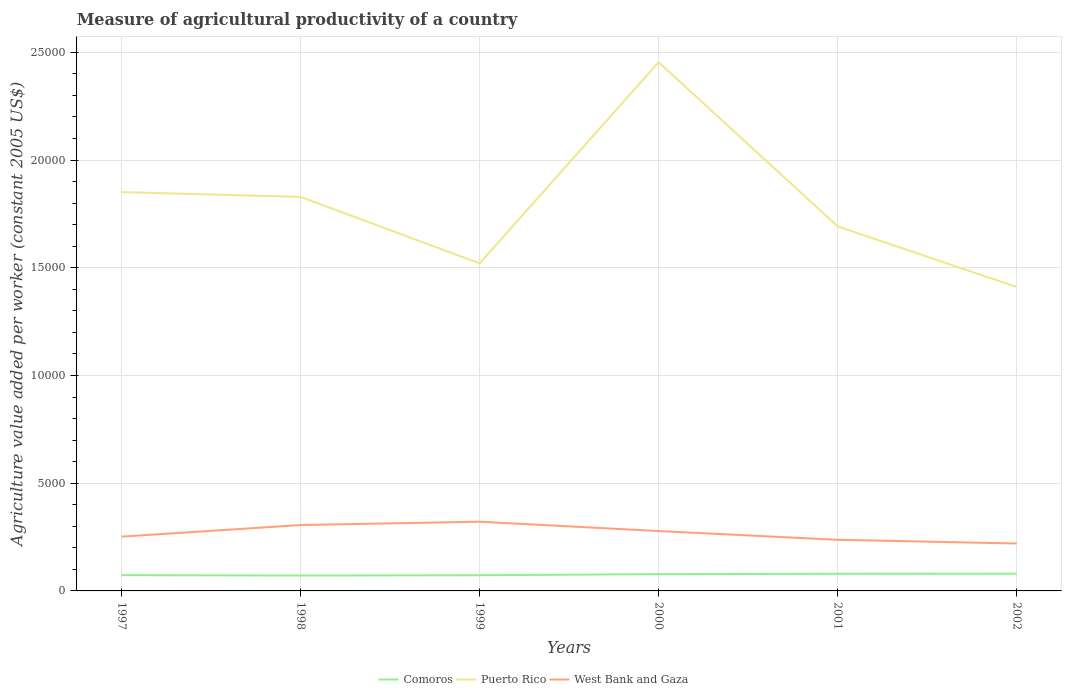Is the number of lines equal to the number of legend labels?
Make the answer very short. Yes. Across all years, what is the maximum measure of agricultural productivity in Puerto Rico?
Your answer should be very brief. 1.41e+04. In which year was the measure of agricultural productivity in West Bank and Gaza maximum?
Offer a very short reply. 2002. What is the total measure of agricultural productivity in Puerto Rico in the graph?
Your answer should be compact. -1714.63. What is the difference between the highest and the second highest measure of agricultural productivity in West Bank and Gaza?
Ensure brevity in your answer.  1012.13. What is the difference between the highest and the lowest measure of agricultural productivity in West Bank and Gaza?
Your answer should be very brief. 3. Is the measure of agricultural productivity in Comoros strictly greater than the measure of agricultural productivity in West Bank and Gaza over the years?
Your answer should be compact. Yes. Are the values on the major ticks of Y-axis written in scientific E-notation?
Your answer should be very brief. No. Does the graph contain any zero values?
Provide a succinct answer. No. Where does the legend appear in the graph?
Keep it short and to the point. Bottom center. What is the title of the graph?
Your answer should be very brief. Measure of agricultural productivity of a country. Does "Djibouti" appear as one of the legend labels in the graph?
Give a very brief answer. No. What is the label or title of the X-axis?
Provide a succinct answer. Years. What is the label or title of the Y-axis?
Your response must be concise. Agriculture value added per worker (constant 2005 US$). What is the Agriculture value added per worker (constant 2005 US$) of Comoros in 1997?
Your answer should be compact. 731.41. What is the Agriculture value added per worker (constant 2005 US$) of Puerto Rico in 1997?
Your answer should be very brief. 1.85e+04. What is the Agriculture value added per worker (constant 2005 US$) in West Bank and Gaza in 1997?
Your answer should be compact. 2520.14. What is the Agriculture value added per worker (constant 2005 US$) of Comoros in 1998?
Your answer should be compact. 714.18. What is the Agriculture value added per worker (constant 2005 US$) in Puerto Rico in 1998?
Your answer should be very brief. 1.83e+04. What is the Agriculture value added per worker (constant 2005 US$) of West Bank and Gaza in 1998?
Offer a very short reply. 3057.49. What is the Agriculture value added per worker (constant 2005 US$) of Comoros in 1999?
Offer a terse response. 727.74. What is the Agriculture value added per worker (constant 2005 US$) of Puerto Rico in 1999?
Keep it short and to the point. 1.52e+04. What is the Agriculture value added per worker (constant 2005 US$) in West Bank and Gaza in 1999?
Make the answer very short. 3212.81. What is the Agriculture value added per worker (constant 2005 US$) in Comoros in 2000?
Your answer should be very brief. 778.83. What is the Agriculture value added per worker (constant 2005 US$) in Puerto Rico in 2000?
Make the answer very short. 2.45e+04. What is the Agriculture value added per worker (constant 2005 US$) in West Bank and Gaza in 2000?
Provide a short and direct response. 2778.67. What is the Agriculture value added per worker (constant 2005 US$) in Comoros in 2001?
Ensure brevity in your answer.  796.84. What is the Agriculture value added per worker (constant 2005 US$) of Puerto Rico in 2001?
Give a very brief answer. 1.69e+04. What is the Agriculture value added per worker (constant 2005 US$) in West Bank and Gaza in 2001?
Keep it short and to the point. 2373.17. What is the Agriculture value added per worker (constant 2005 US$) of Comoros in 2002?
Your response must be concise. 800.25. What is the Agriculture value added per worker (constant 2005 US$) of Puerto Rico in 2002?
Make the answer very short. 1.41e+04. What is the Agriculture value added per worker (constant 2005 US$) in West Bank and Gaza in 2002?
Your response must be concise. 2200.68. Across all years, what is the maximum Agriculture value added per worker (constant 2005 US$) in Comoros?
Your answer should be very brief. 800.25. Across all years, what is the maximum Agriculture value added per worker (constant 2005 US$) of Puerto Rico?
Make the answer very short. 2.45e+04. Across all years, what is the maximum Agriculture value added per worker (constant 2005 US$) in West Bank and Gaza?
Provide a short and direct response. 3212.81. Across all years, what is the minimum Agriculture value added per worker (constant 2005 US$) of Comoros?
Your answer should be compact. 714.18. Across all years, what is the minimum Agriculture value added per worker (constant 2005 US$) of Puerto Rico?
Give a very brief answer. 1.41e+04. Across all years, what is the minimum Agriculture value added per worker (constant 2005 US$) of West Bank and Gaza?
Ensure brevity in your answer.  2200.68. What is the total Agriculture value added per worker (constant 2005 US$) in Comoros in the graph?
Provide a short and direct response. 4549.26. What is the total Agriculture value added per worker (constant 2005 US$) of Puerto Rico in the graph?
Make the answer very short. 1.08e+05. What is the total Agriculture value added per worker (constant 2005 US$) of West Bank and Gaza in the graph?
Your answer should be compact. 1.61e+04. What is the difference between the Agriculture value added per worker (constant 2005 US$) of Comoros in 1997 and that in 1998?
Your answer should be compact. 17.24. What is the difference between the Agriculture value added per worker (constant 2005 US$) in Puerto Rico in 1997 and that in 1998?
Give a very brief answer. 222.44. What is the difference between the Agriculture value added per worker (constant 2005 US$) in West Bank and Gaza in 1997 and that in 1998?
Offer a very short reply. -537.35. What is the difference between the Agriculture value added per worker (constant 2005 US$) in Comoros in 1997 and that in 1999?
Your answer should be very brief. 3.67. What is the difference between the Agriculture value added per worker (constant 2005 US$) of Puerto Rico in 1997 and that in 1999?
Give a very brief answer. 3308.77. What is the difference between the Agriculture value added per worker (constant 2005 US$) in West Bank and Gaza in 1997 and that in 1999?
Ensure brevity in your answer.  -692.67. What is the difference between the Agriculture value added per worker (constant 2005 US$) in Comoros in 1997 and that in 2000?
Provide a short and direct response. -47.42. What is the difference between the Agriculture value added per worker (constant 2005 US$) in Puerto Rico in 1997 and that in 2000?
Your answer should be compact. -6026.43. What is the difference between the Agriculture value added per worker (constant 2005 US$) in West Bank and Gaza in 1997 and that in 2000?
Provide a succinct answer. -258.53. What is the difference between the Agriculture value added per worker (constant 2005 US$) in Comoros in 1997 and that in 2001?
Your response must be concise. -65.43. What is the difference between the Agriculture value added per worker (constant 2005 US$) in Puerto Rico in 1997 and that in 2001?
Your answer should be very brief. 1594.14. What is the difference between the Agriculture value added per worker (constant 2005 US$) of West Bank and Gaza in 1997 and that in 2001?
Offer a terse response. 146.97. What is the difference between the Agriculture value added per worker (constant 2005 US$) in Comoros in 1997 and that in 2002?
Your response must be concise. -68.84. What is the difference between the Agriculture value added per worker (constant 2005 US$) of Puerto Rico in 1997 and that in 2002?
Make the answer very short. 4405.29. What is the difference between the Agriculture value added per worker (constant 2005 US$) of West Bank and Gaza in 1997 and that in 2002?
Keep it short and to the point. 319.46. What is the difference between the Agriculture value added per worker (constant 2005 US$) in Comoros in 1998 and that in 1999?
Provide a short and direct response. -13.57. What is the difference between the Agriculture value added per worker (constant 2005 US$) of Puerto Rico in 1998 and that in 1999?
Ensure brevity in your answer.  3086.33. What is the difference between the Agriculture value added per worker (constant 2005 US$) in West Bank and Gaza in 1998 and that in 1999?
Your response must be concise. -155.32. What is the difference between the Agriculture value added per worker (constant 2005 US$) in Comoros in 1998 and that in 2000?
Offer a terse response. -64.65. What is the difference between the Agriculture value added per worker (constant 2005 US$) of Puerto Rico in 1998 and that in 2000?
Provide a short and direct response. -6248.87. What is the difference between the Agriculture value added per worker (constant 2005 US$) of West Bank and Gaza in 1998 and that in 2000?
Offer a terse response. 278.81. What is the difference between the Agriculture value added per worker (constant 2005 US$) of Comoros in 1998 and that in 2001?
Offer a very short reply. -82.66. What is the difference between the Agriculture value added per worker (constant 2005 US$) in Puerto Rico in 1998 and that in 2001?
Your answer should be compact. 1371.7. What is the difference between the Agriculture value added per worker (constant 2005 US$) in West Bank and Gaza in 1998 and that in 2001?
Offer a very short reply. 684.31. What is the difference between the Agriculture value added per worker (constant 2005 US$) of Comoros in 1998 and that in 2002?
Offer a terse response. -86.07. What is the difference between the Agriculture value added per worker (constant 2005 US$) of Puerto Rico in 1998 and that in 2002?
Your answer should be compact. 4182.85. What is the difference between the Agriculture value added per worker (constant 2005 US$) of West Bank and Gaza in 1998 and that in 2002?
Ensure brevity in your answer.  856.81. What is the difference between the Agriculture value added per worker (constant 2005 US$) of Comoros in 1999 and that in 2000?
Your answer should be compact. -51.09. What is the difference between the Agriculture value added per worker (constant 2005 US$) in Puerto Rico in 1999 and that in 2000?
Provide a succinct answer. -9335.2. What is the difference between the Agriculture value added per worker (constant 2005 US$) in West Bank and Gaza in 1999 and that in 2000?
Ensure brevity in your answer.  434.13. What is the difference between the Agriculture value added per worker (constant 2005 US$) of Comoros in 1999 and that in 2001?
Ensure brevity in your answer.  -69.1. What is the difference between the Agriculture value added per worker (constant 2005 US$) in Puerto Rico in 1999 and that in 2001?
Ensure brevity in your answer.  -1714.63. What is the difference between the Agriculture value added per worker (constant 2005 US$) of West Bank and Gaza in 1999 and that in 2001?
Ensure brevity in your answer.  839.63. What is the difference between the Agriculture value added per worker (constant 2005 US$) of Comoros in 1999 and that in 2002?
Your answer should be compact. -72.51. What is the difference between the Agriculture value added per worker (constant 2005 US$) in Puerto Rico in 1999 and that in 2002?
Your answer should be very brief. 1096.52. What is the difference between the Agriculture value added per worker (constant 2005 US$) of West Bank and Gaza in 1999 and that in 2002?
Offer a terse response. 1012.13. What is the difference between the Agriculture value added per worker (constant 2005 US$) of Comoros in 2000 and that in 2001?
Your answer should be compact. -18.01. What is the difference between the Agriculture value added per worker (constant 2005 US$) of Puerto Rico in 2000 and that in 2001?
Keep it short and to the point. 7620.57. What is the difference between the Agriculture value added per worker (constant 2005 US$) in West Bank and Gaza in 2000 and that in 2001?
Your answer should be very brief. 405.5. What is the difference between the Agriculture value added per worker (constant 2005 US$) in Comoros in 2000 and that in 2002?
Provide a succinct answer. -21.42. What is the difference between the Agriculture value added per worker (constant 2005 US$) of Puerto Rico in 2000 and that in 2002?
Provide a succinct answer. 1.04e+04. What is the difference between the Agriculture value added per worker (constant 2005 US$) in West Bank and Gaza in 2000 and that in 2002?
Ensure brevity in your answer.  577.99. What is the difference between the Agriculture value added per worker (constant 2005 US$) of Comoros in 2001 and that in 2002?
Provide a short and direct response. -3.41. What is the difference between the Agriculture value added per worker (constant 2005 US$) of Puerto Rico in 2001 and that in 2002?
Keep it short and to the point. 2811.15. What is the difference between the Agriculture value added per worker (constant 2005 US$) in West Bank and Gaza in 2001 and that in 2002?
Offer a very short reply. 172.49. What is the difference between the Agriculture value added per worker (constant 2005 US$) of Comoros in 1997 and the Agriculture value added per worker (constant 2005 US$) of Puerto Rico in 1998?
Your answer should be compact. -1.76e+04. What is the difference between the Agriculture value added per worker (constant 2005 US$) of Comoros in 1997 and the Agriculture value added per worker (constant 2005 US$) of West Bank and Gaza in 1998?
Your response must be concise. -2326.07. What is the difference between the Agriculture value added per worker (constant 2005 US$) of Puerto Rico in 1997 and the Agriculture value added per worker (constant 2005 US$) of West Bank and Gaza in 1998?
Provide a short and direct response. 1.55e+04. What is the difference between the Agriculture value added per worker (constant 2005 US$) of Comoros in 1997 and the Agriculture value added per worker (constant 2005 US$) of Puerto Rico in 1999?
Keep it short and to the point. -1.45e+04. What is the difference between the Agriculture value added per worker (constant 2005 US$) in Comoros in 1997 and the Agriculture value added per worker (constant 2005 US$) in West Bank and Gaza in 1999?
Provide a succinct answer. -2481.39. What is the difference between the Agriculture value added per worker (constant 2005 US$) in Puerto Rico in 1997 and the Agriculture value added per worker (constant 2005 US$) in West Bank and Gaza in 1999?
Your answer should be very brief. 1.53e+04. What is the difference between the Agriculture value added per worker (constant 2005 US$) in Comoros in 1997 and the Agriculture value added per worker (constant 2005 US$) in Puerto Rico in 2000?
Your response must be concise. -2.38e+04. What is the difference between the Agriculture value added per worker (constant 2005 US$) in Comoros in 1997 and the Agriculture value added per worker (constant 2005 US$) in West Bank and Gaza in 2000?
Your answer should be compact. -2047.26. What is the difference between the Agriculture value added per worker (constant 2005 US$) of Puerto Rico in 1997 and the Agriculture value added per worker (constant 2005 US$) of West Bank and Gaza in 2000?
Make the answer very short. 1.57e+04. What is the difference between the Agriculture value added per worker (constant 2005 US$) in Comoros in 1997 and the Agriculture value added per worker (constant 2005 US$) in Puerto Rico in 2001?
Your response must be concise. -1.62e+04. What is the difference between the Agriculture value added per worker (constant 2005 US$) in Comoros in 1997 and the Agriculture value added per worker (constant 2005 US$) in West Bank and Gaza in 2001?
Make the answer very short. -1641.76. What is the difference between the Agriculture value added per worker (constant 2005 US$) in Puerto Rico in 1997 and the Agriculture value added per worker (constant 2005 US$) in West Bank and Gaza in 2001?
Offer a terse response. 1.61e+04. What is the difference between the Agriculture value added per worker (constant 2005 US$) in Comoros in 1997 and the Agriculture value added per worker (constant 2005 US$) in Puerto Rico in 2002?
Offer a very short reply. -1.34e+04. What is the difference between the Agriculture value added per worker (constant 2005 US$) of Comoros in 1997 and the Agriculture value added per worker (constant 2005 US$) of West Bank and Gaza in 2002?
Ensure brevity in your answer.  -1469.27. What is the difference between the Agriculture value added per worker (constant 2005 US$) in Puerto Rico in 1997 and the Agriculture value added per worker (constant 2005 US$) in West Bank and Gaza in 2002?
Give a very brief answer. 1.63e+04. What is the difference between the Agriculture value added per worker (constant 2005 US$) in Comoros in 1998 and the Agriculture value added per worker (constant 2005 US$) in Puerto Rico in 1999?
Make the answer very short. -1.45e+04. What is the difference between the Agriculture value added per worker (constant 2005 US$) in Comoros in 1998 and the Agriculture value added per worker (constant 2005 US$) in West Bank and Gaza in 1999?
Provide a succinct answer. -2498.63. What is the difference between the Agriculture value added per worker (constant 2005 US$) of Puerto Rico in 1998 and the Agriculture value added per worker (constant 2005 US$) of West Bank and Gaza in 1999?
Your response must be concise. 1.51e+04. What is the difference between the Agriculture value added per worker (constant 2005 US$) of Comoros in 1998 and the Agriculture value added per worker (constant 2005 US$) of Puerto Rico in 2000?
Make the answer very short. -2.38e+04. What is the difference between the Agriculture value added per worker (constant 2005 US$) in Comoros in 1998 and the Agriculture value added per worker (constant 2005 US$) in West Bank and Gaza in 2000?
Give a very brief answer. -2064.49. What is the difference between the Agriculture value added per worker (constant 2005 US$) of Puerto Rico in 1998 and the Agriculture value added per worker (constant 2005 US$) of West Bank and Gaza in 2000?
Offer a terse response. 1.55e+04. What is the difference between the Agriculture value added per worker (constant 2005 US$) in Comoros in 1998 and the Agriculture value added per worker (constant 2005 US$) in Puerto Rico in 2001?
Ensure brevity in your answer.  -1.62e+04. What is the difference between the Agriculture value added per worker (constant 2005 US$) of Comoros in 1998 and the Agriculture value added per worker (constant 2005 US$) of West Bank and Gaza in 2001?
Make the answer very short. -1658.99. What is the difference between the Agriculture value added per worker (constant 2005 US$) of Puerto Rico in 1998 and the Agriculture value added per worker (constant 2005 US$) of West Bank and Gaza in 2001?
Keep it short and to the point. 1.59e+04. What is the difference between the Agriculture value added per worker (constant 2005 US$) in Comoros in 1998 and the Agriculture value added per worker (constant 2005 US$) in Puerto Rico in 2002?
Ensure brevity in your answer.  -1.34e+04. What is the difference between the Agriculture value added per worker (constant 2005 US$) of Comoros in 1998 and the Agriculture value added per worker (constant 2005 US$) of West Bank and Gaza in 2002?
Your answer should be compact. -1486.5. What is the difference between the Agriculture value added per worker (constant 2005 US$) in Puerto Rico in 1998 and the Agriculture value added per worker (constant 2005 US$) in West Bank and Gaza in 2002?
Provide a short and direct response. 1.61e+04. What is the difference between the Agriculture value added per worker (constant 2005 US$) in Comoros in 1999 and the Agriculture value added per worker (constant 2005 US$) in Puerto Rico in 2000?
Ensure brevity in your answer.  -2.38e+04. What is the difference between the Agriculture value added per worker (constant 2005 US$) in Comoros in 1999 and the Agriculture value added per worker (constant 2005 US$) in West Bank and Gaza in 2000?
Offer a very short reply. -2050.93. What is the difference between the Agriculture value added per worker (constant 2005 US$) of Puerto Rico in 1999 and the Agriculture value added per worker (constant 2005 US$) of West Bank and Gaza in 2000?
Your response must be concise. 1.24e+04. What is the difference between the Agriculture value added per worker (constant 2005 US$) in Comoros in 1999 and the Agriculture value added per worker (constant 2005 US$) in Puerto Rico in 2001?
Your response must be concise. -1.62e+04. What is the difference between the Agriculture value added per worker (constant 2005 US$) of Comoros in 1999 and the Agriculture value added per worker (constant 2005 US$) of West Bank and Gaza in 2001?
Your response must be concise. -1645.43. What is the difference between the Agriculture value added per worker (constant 2005 US$) in Puerto Rico in 1999 and the Agriculture value added per worker (constant 2005 US$) in West Bank and Gaza in 2001?
Your answer should be very brief. 1.28e+04. What is the difference between the Agriculture value added per worker (constant 2005 US$) of Comoros in 1999 and the Agriculture value added per worker (constant 2005 US$) of Puerto Rico in 2002?
Give a very brief answer. -1.34e+04. What is the difference between the Agriculture value added per worker (constant 2005 US$) of Comoros in 1999 and the Agriculture value added per worker (constant 2005 US$) of West Bank and Gaza in 2002?
Ensure brevity in your answer.  -1472.94. What is the difference between the Agriculture value added per worker (constant 2005 US$) in Puerto Rico in 1999 and the Agriculture value added per worker (constant 2005 US$) in West Bank and Gaza in 2002?
Provide a succinct answer. 1.30e+04. What is the difference between the Agriculture value added per worker (constant 2005 US$) of Comoros in 2000 and the Agriculture value added per worker (constant 2005 US$) of Puerto Rico in 2001?
Make the answer very short. -1.61e+04. What is the difference between the Agriculture value added per worker (constant 2005 US$) in Comoros in 2000 and the Agriculture value added per worker (constant 2005 US$) in West Bank and Gaza in 2001?
Make the answer very short. -1594.34. What is the difference between the Agriculture value added per worker (constant 2005 US$) of Puerto Rico in 2000 and the Agriculture value added per worker (constant 2005 US$) of West Bank and Gaza in 2001?
Offer a very short reply. 2.22e+04. What is the difference between the Agriculture value added per worker (constant 2005 US$) of Comoros in 2000 and the Agriculture value added per worker (constant 2005 US$) of Puerto Rico in 2002?
Provide a short and direct response. -1.33e+04. What is the difference between the Agriculture value added per worker (constant 2005 US$) in Comoros in 2000 and the Agriculture value added per worker (constant 2005 US$) in West Bank and Gaza in 2002?
Ensure brevity in your answer.  -1421.85. What is the difference between the Agriculture value added per worker (constant 2005 US$) of Puerto Rico in 2000 and the Agriculture value added per worker (constant 2005 US$) of West Bank and Gaza in 2002?
Give a very brief answer. 2.23e+04. What is the difference between the Agriculture value added per worker (constant 2005 US$) of Comoros in 2001 and the Agriculture value added per worker (constant 2005 US$) of Puerto Rico in 2002?
Ensure brevity in your answer.  -1.33e+04. What is the difference between the Agriculture value added per worker (constant 2005 US$) in Comoros in 2001 and the Agriculture value added per worker (constant 2005 US$) in West Bank and Gaza in 2002?
Provide a succinct answer. -1403.84. What is the difference between the Agriculture value added per worker (constant 2005 US$) in Puerto Rico in 2001 and the Agriculture value added per worker (constant 2005 US$) in West Bank and Gaza in 2002?
Your answer should be very brief. 1.47e+04. What is the average Agriculture value added per worker (constant 2005 US$) of Comoros per year?
Provide a short and direct response. 758.21. What is the average Agriculture value added per worker (constant 2005 US$) in Puerto Rico per year?
Your answer should be compact. 1.79e+04. What is the average Agriculture value added per worker (constant 2005 US$) of West Bank and Gaza per year?
Make the answer very short. 2690.49. In the year 1997, what is the difference between the Agriculture value added per worker (constant 2005 US$) of Comoros and Agriculture value added per worker (constant 2005 US$) of Puerto Rico?
Keep it short and to the point. -1.78e+04. In the year 1997, what is the difference between the Agriculture value added per worker (constant 2005 US$) of Comoros and Agriculture value added per worker (constant 2005 US$) of West Bank and Gaza?
Provide a short and direct response. -1788.73. In the year 1997, what is the difference between the Agriculture value added per worker (constant 2005 US$) of Puerto Rico and Agriculture value added per worker (constant 2005 US$) of West Bank and Gaza?
Provide a short and direct response. 1.60e+04. In the year 1998, what is the difference between the Agriculture value added per worker (constant 2005 US$) of Comoros and Agriculture value added per worker (constant 2005 US$) of Puerto Rico?
Ensure brevity in your answer.  -1.76e+04. In the year 1998, what is the difference between the Agriculture value added per worker (constant 2005 US$) in Comoros and Agriculture value added per worker (constant 2005 US$) in West Bank and Gaza?
Give a very brief answer. -2343.31. In the year 1998, what is the difference between the Agriculture value added per worker (constant 2005 US$) of Puerto Rico and Agriculture value added per worker (constant 2005 US$) of West Bank and Gaza?
Your response must be concise. 1.52e+04. In the year 1999, what is the difference between the Agriculture value added per worker (constant 2005 US$) in Comoros and Agriculture value added per worker (constant 2005 US$) in Puerto Rico?
Provide a succinct answer. -1.45e+04. In the year 1999, what is the difference between the Agriculture value added per worker (constant 2005 US$) in Comoros and Agriculture value added per worker (constant 2005 US$) in West Bank and Gaza?
Provide a succinct answer. -2485.06. In the year 1999, what is the difference between the Agriculture value added per worker (constant 2005 US$) in Puerto Rico and Agriculture value added per worker (constant 2005 US$) in West Bank and Gaza?
Your response must be concise. 1.20e+04. In the year 2000, what is the difference between the Agriculture value added per worker (constant 2005 US$) of Comoros and Agriculture value added per worker (constant 2005 US$) of Puerto Rico?
Ensure brevity in your answer.  -2.38e+04. In the year 2000, what is the difference between the Agriculture value added per worker (constant 2005 US$) in Comoros and Agriculture value added per worker (constant 2005 US$) in West Bank and Gaza?
Give a very brief answer. -1999.84. In the year 2000, what is the difference between the Agriculture value added per worker (constant 2005 US$) in Puerto Rico and Agriculture value added per worker (constant 2005 US$) in West Bank and Gaza?
Make the answer very short. 2.18e+04. In the year 2001, what is the difference between the Agriculture value added per worker (constant 2005 US$) of Comoros and Agriculture value added per worker (constant 2005 US$) of Puerto Rico?
Offer a terse response. -1.61e+04. In the year 2001, what is the difference between the Agriculture value added per worker (constant 2005 US$) of Comoros and Agriculture value added per worker (constant 2005 US$) of West Bank and Gaza?
Keep it short and to the point. -1576.33. In the year 2001, what is the difference between the Agriculture value added per worker (constant 2005 US$) of Puerto Rico and Agriculture value added per worker (constant 2005 US$) of West Bank and Gaza?
Give a very brief answer. 1.45e+04. In the year 2002, what is the difference between the Agriculture value added per worker (constant 2005 US$) in Comoros and Agriculture value added per worker (constant 2005 US$) in Puerto Rico?
Provide a short and direct response. -1.33e+04. In the year 2002, what is the difference between the Agriculture value added per worker (constant 2005 US$) of Comoros and Agriculture value added per worker (constant 2005 US$) of West Bank and Gaza?
Offer a terse response. -1400.43. In the year 2002, what is the difference between the Agriculture value added per worker (constant 2005 US$) of Puerto Rico and Agriculture value added per worker (constant 2005 US$) of West Bank and Gaza?
Your answer should be compact. 1.19e+04. What is the ratio of the Agriculture value added per worker (constant 2005 US$) in Comoros in 1997 to that in 1998?
Your answer should be very brief. 1.02. What is the ratio of the Agriculture value added per worker (constant 2005 US$) of Puerto Rico in 1997 to that in 1998?
Provide a succinct answer. 1.01. What is the ratio of the Agriculture value added per worker (constant 2005 US$) in West Bank and Gaza in 1997 to that in 1998?
Your answer should be very brief. 0.82. What is the ratio of the Agriculture value added per worker (constant 2005 US$) of Comoros in 1997 to that in 1999?
Give a very brief answer. 1. What is the ratio of the Agriculture value added per worker (constant 2005 US$) in Puerto Rico in 1997 to that in 1999?
Offer a terse response. 1.22. What is the ratio of the Agriculture value added per worker (constant 2005 US$) in West Bank and Gaza in 1997 to that in 1999?
Your answer should be very brief. 0.78. What is the ratio of the Agriculture value added per worker (constant 2005 US$) in Comoros in 1997 to that in 2000?
Give a very brief answer. 0.94. What is the ratio of the Agriculture value added per worker (constant 2005 US$) of Puerto Rico in 1997 to that in 2000?
Make the answer very short. 0.75. What is the ratio of the Agriculture value added per worker (constant 2005 US$) of West Bank and Gaza in 1997 to that in 2000?
Your response must be concise. 0.91. What is the ratio of the Agriculture value added per worker (constant 2005 US$) of Comoros in 1997 to that in 2001?
Provide a succinct answer. 0.92. What is the ratio of the Agriculture value added per worker (constant 2005 US$) of Puerto Rico in 1997 to that in 2001?
Your answer should be very brief. 1.09. What is the ratio of the Agriculture value added per worker (constant 2005 US$) in West Bank and Gaza in 1997 to that in 2001?
Keep it short and to the point. 1.06. What is the ratio of the Agriculture value added per worker (constant 2005 US$) in Comoros in 1997 to that in 2002?
Offer a very short reply. 0.91. What is the ratio of the Agriculture value added per worker (constant 2005 US$) of Puerto Rico in 1997 to that in 2002?
Make the answer very short. 1.31. What is the ratio of the Agriculture value added per worker (constant 2005 US$) of West Bank and Gaza in 1997 to that in 2002?
Provide a succinct answer. 1.15. What is the ratio of the Agriculture value added per worker (constant 2005 US$) of Comoros in 1998 to that in 1999?
Give a very brief answer. 0.98. What is the ratio of the Agriculture value added per worker (constant 2005 US$) of Puerto Rico in 1998 to that in 1999?
Your answer should be compact. 1.2. What is the ratio of the Agriculture value added per worker (constant 2005 US$) in West Bank and Gaza in 1998 to that in 1999?
Give a very brief answer. 0.95. What is the ratio of the Agriculture value added per worker (constant 2005 US$) in Comoros in 1998 to that in 2000?
Offer a very short reply. 0.92. What is the ratio of the Agriculture value added per worker (constant 2005 US$) in Puerto Rico in 1998 to that in 2000?
Keep it short and to the point. 0.75. What is the ratio of the Agriculture value added per worker (constant 2005 US$) of West Bank and Gaza in 1998 to that in 2000?
Offer a terse response. 1.1. What is the ratio of the Agriculture value added per worker (constant 2005 US$) in Comoros in 1998 to that in 2001?
Offer a very short reply. 0.9. What is the ratio of the Agriculture value added per worker (constant 2005 US$) in Puerto Rico in 1998 to that in 2001?
Offer a terse response. 1.08. What is the ratio of the Agriculture value added per worker (constant 2005 US$) of West Bank and Gaza in 1998 to that in 2001?
Provide a short and direct response. 1.29. What is the ratio of the Agriculture value added per worker (constant 2005 US$) of Comoros in 1998 to that in 2002?
Make the answer very short. 0.89. What is the ratio of the Agriculture value added per worker (constant 2005 US$) in Puerto Rico in 1998 to that in 2002?
Offer a terse response. 1.3. What is the ratio of the Agriculture value added per worker (constant 2005 US$) of West Bank and Gaza in 1998 to that in 2002?
Provide a short and direct response. 1.39. What is the ratio of the Agriculture value added per worker (constant 2005 US$) of Comoros in 1999 to that in 2000?
Your response must be concise. 0.93. What is the ratio of the Agriculture value added per worker (constant 2005 US$) in Puerto Rico in 1999 to that in 2000?
Make the answer very short. 0.62. What is the ratio of the Agriculture value added per worker (constant 2005 US$) of West Bank and Gaza in 1999 to that in 2000?
Give a very brief answer. 1.16. What is the ratio of the Agriculture value added per worker (constant 2005 US$) in Comoros in 1999 to that in 2001?
Offer a terse response. 0.91. What is the ratio of the Agriculture value added per worker (constant 2005 US$) of Puerto Rico in 1999 to that in 2001?
Make the answer very short. 0.9. What is the ratio of the Agriculture value added per worker (constant 2005 US$) of West Bank and Gaza in 1999 to that in 2001?
Ensure brevity in your answer.  1.35. What is the ratio of the Agriculture value added per worker (constant 2005 US$) in Comoros in 1999 to that in 2002?
Provide a short and direct response. 0.91. What is the ratio of the Agriculture value added per worker (constant 2005 US$) in Puerto Rico in 1999 to that in 2002?
Ensure brevity in your answer.  1.08. What is the ratio of the Agriculture value added per worker (constant 2005 US$) of West Bank and Gaza in 1999 to that in 2002?
Your response must be concise. 1.46. What is the ratio of the Agriculture value added per worker (constant 2005 US$) of Comoros in 2000 to that in 2001?
Offer a terse response. 0.98. What is the ratio of the Agriculture value added per worker (constant 2005 US$) in Puerto Rico in 2000 to that in 2001?
Keep it short and to the point. 1.45. What is the ratio of the Agriculture value added per worker (constant 2005 US$) of West Bank and Gaza in 2000 to that in 2001?
Your response must be concise. 1.17. What is the ratio of the Agriculture value added per worker (constant 2005 US$) of Comoros in 2000 to that in 2002?
Your response must be concise. 0.97. What is the ratio of the Agriculture value added per worker (constant 2005 US$) of Puerto Rico in 2000 to that in 2002?
Give a very brief answer. 1.74. What is the ratio of the Agriculture value added per worker (constant 2005 US$) of West Bank and Gaza in 2000 to that in 2002?
Your response must be concise. 1.26. What is the ratio of the Agriculture value added per worker (constant 2005 US$) in Puerto Rico in 2001 to that in 2002?
Your answer should be compact. 1.2. What is the ratio of the Agriculture value added per worker (constant 2005 US$) in West Bank and Gaza in 2001 to that in 2002?
Offer a terse response. 1.08. What is the difference between the highest and the second highest Agriculture value added per worker (constant 2005 US$) of Comoros?
Ensure brevity in your answer.  3.41. What is the difference between the highest and the second highest Agriculture value added per worker (constant 2005 US$) of Puerto Rico?
Offer a very short reply. 6026.43. What is the difference between the highest and the second highest Agriculture value added per worker (constant 2005 US$) in West Bank and Gaza?
Provide a succinct answer. 155.32. What is the difference between the highest and the lowest Agriculture value added per worker (constant 2005 US$) in Comoros?
Ensure brevity in your answer.  86.07. What is the difference between the highest and the lowest Agriculture value added per worker (constant 2005 US$) of Puerto Rico?
Offer a terse response. 1.04e+04. What is the difference between the highest and the lowest Agriculture value added per worker (constant 2005 US$) in West Bank and Gaza?
Give a very brief answer. 1012.13. 